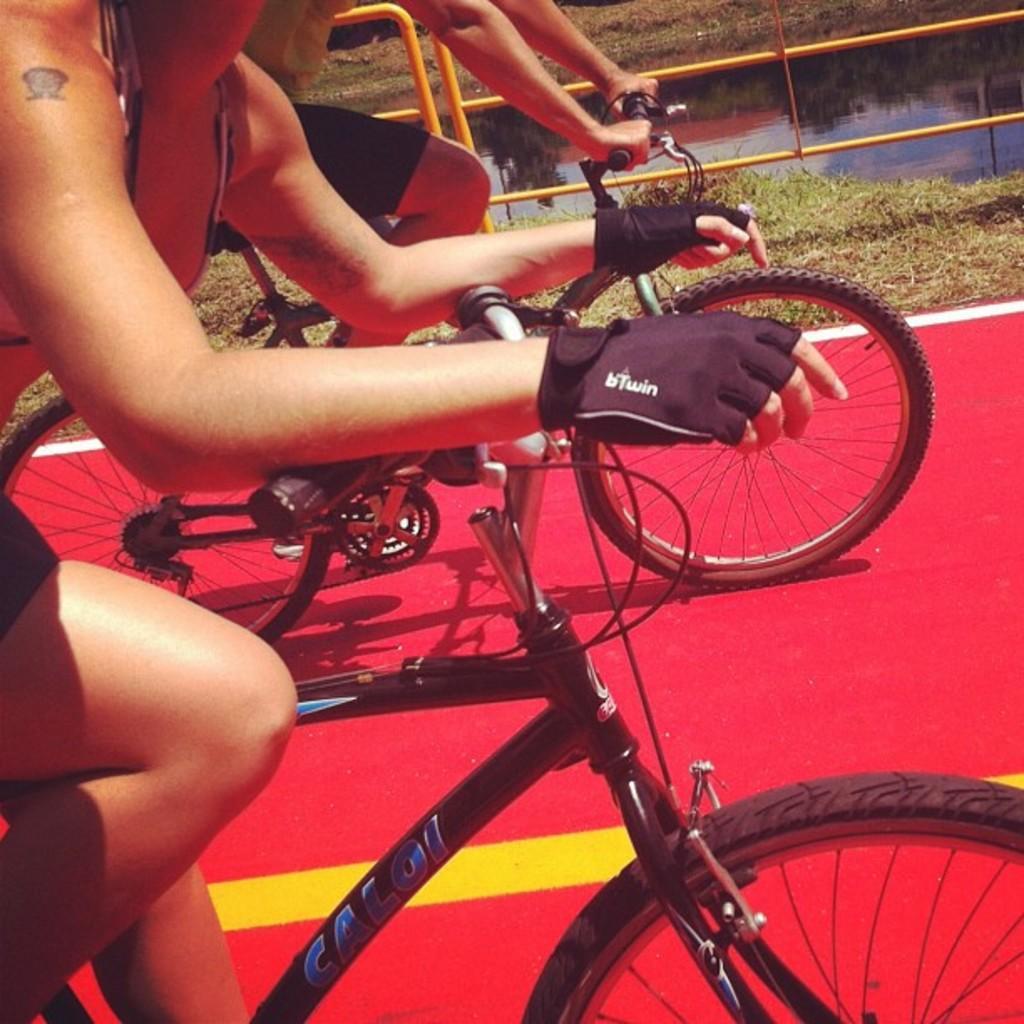How would you summarize this image in a sentence or two? In this image we can see a man and a woman riding bicycles on the ground. We can also see a fence, grass and the water. 